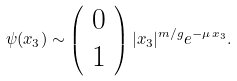<formula> <loc_0><loc_0><loc_500><loc_500>\psi ( x _ { 3 } ) \sim \left ( \begin{array} { c } 0 \\ 1 \end{array} \right ) | x _ { 3 } | ^ { m / g } e ^ { - \mu \, x _ { 3 } } .</formula> 